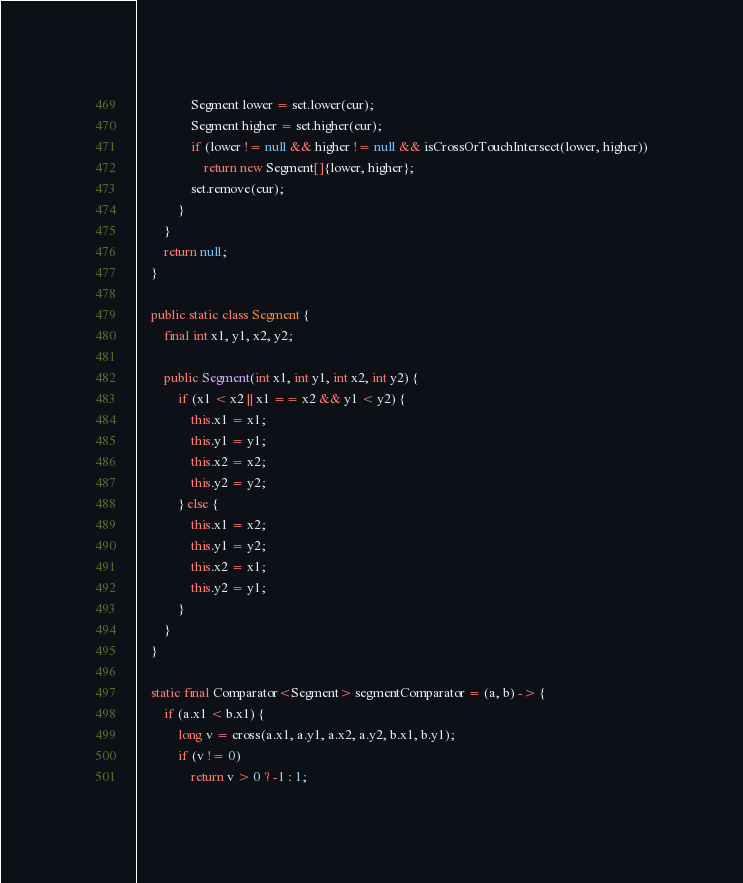Convert code to text. <code><loc_0><loc_0><loc_500><loc_500><_Java_>				Segment lower = set.lower(cur);
				Segment higher = set.higher(cur);
				if (lower != null && higher != null && isCrossOrTouchIntersect(lower, higher))
					return new Segment[]{lower, higher};
				set.remove(cur);
			}
		}
		return null;
	}

	public static class Segment {
		final int x1, y1, x2, y2;

		public Segment(int x1, int y1, int x2, int y2) {
			if (x1 < x2 || x1 == x2 && y1 < y2) {
				this.x1 = x1;
				this.y1 = y1;
				this.x2 = x2;
				this.y2 = y2;
			} else {
				this.x1 = x2;
				this.y1 = y2;
				this.x2 = x1;
				this.y2 = y1;
			}
		}
	}

	static final Comparator<Segment> segmentComparator = (a, b) -> {
		if (a.x1 < b.x1) {
			long v = cross(a.x1, a.y1, a.x2, a.y2, b.x1, b.y1);
			if (v != 0)
				return v > 0 ? -1 : 1;</code> 